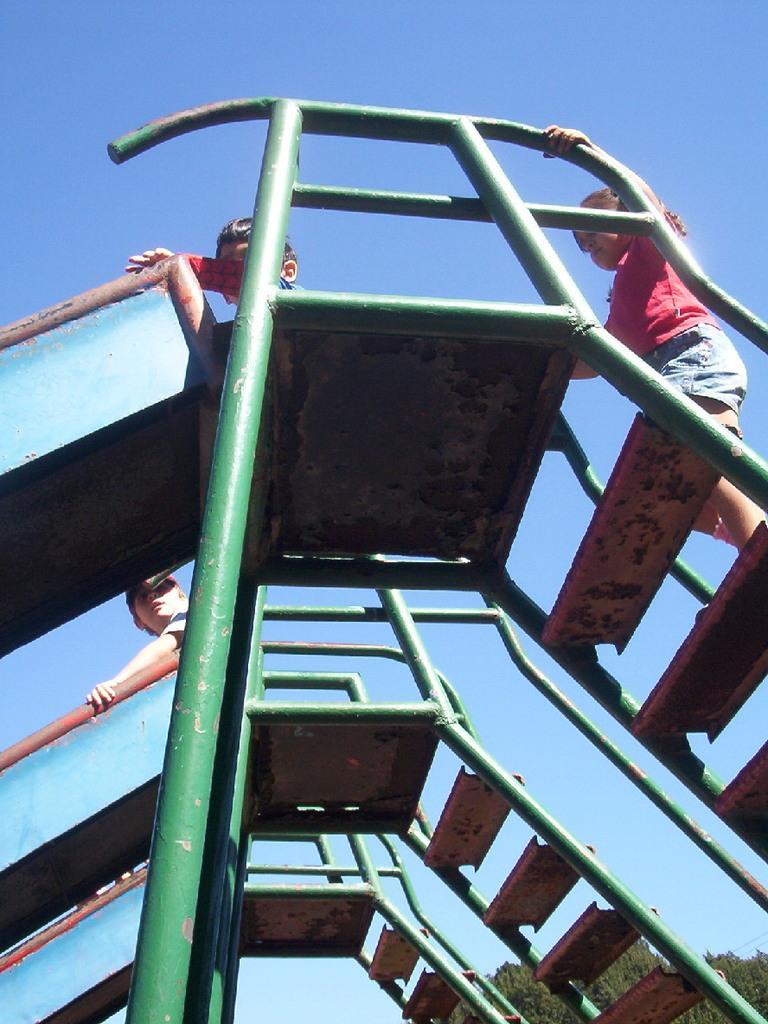In one or two sentences, can you explain what this image depicts? In the foreground of this image, there are three slides on which there are kids standing and sitting. In the background, there are trees and the sky. 